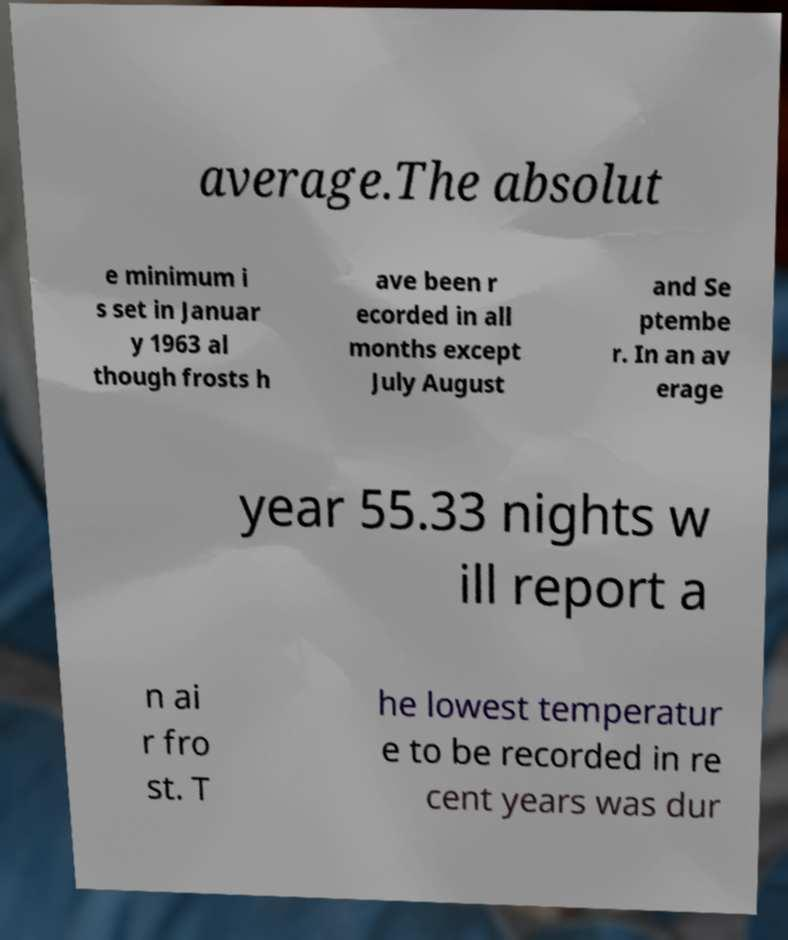Can you read and provide the text displayed in the image?This photo seems to have some interesting text. Can you extract and type it out for me? average.The absolut e minimum i s set in Januar y 1963 al though frosts h ave been r ecorded in all months except July August and Se ptembe r. In an av erage year 55.33 nights w ill report a n ai r fro st. T he lowest temperatur e to be recorded in re cent years was dur 